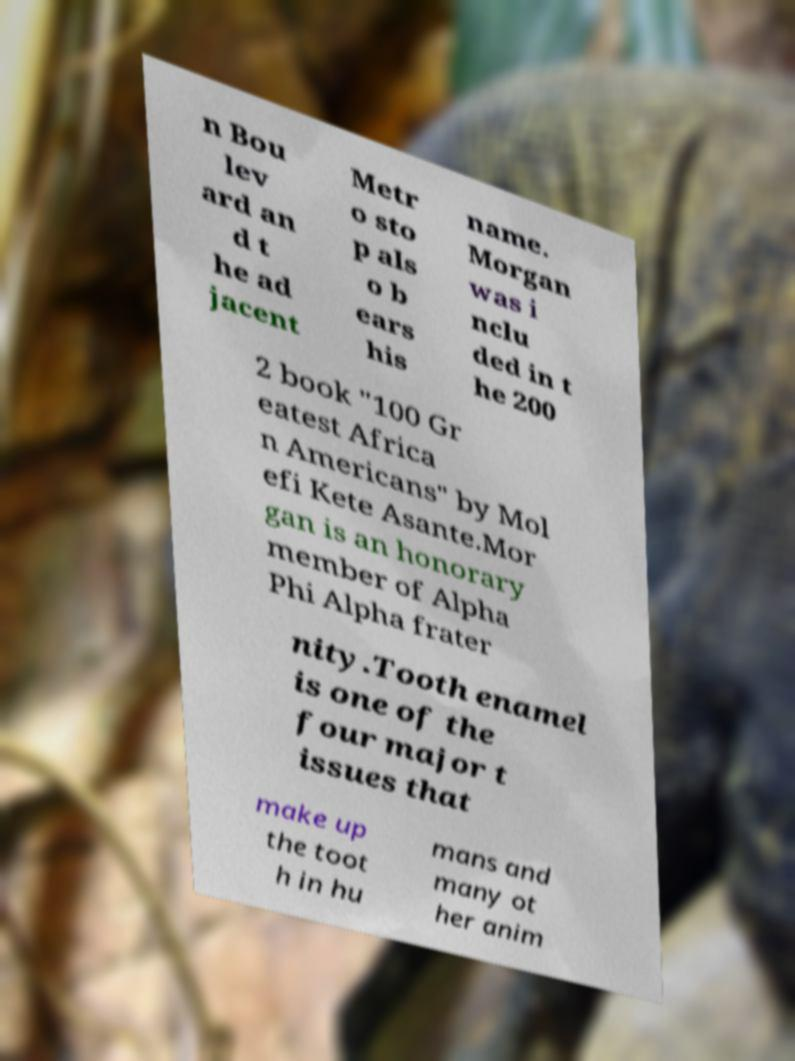Could you extract and type out the text from this image? n Bou lev ard an d t he ad jacent Metr o sto p als o b ears his name. Morgan was i nclu ded in t he 200 2 book "100 Gr eatest Africa n Americans" by Mol efi Kete Asante.Mor gan is an honorary member of Alpha Phi Alpha frater nity.Tooth enamel is one of the four major t issues that make up the toot h in hu mans and many ot her anim 